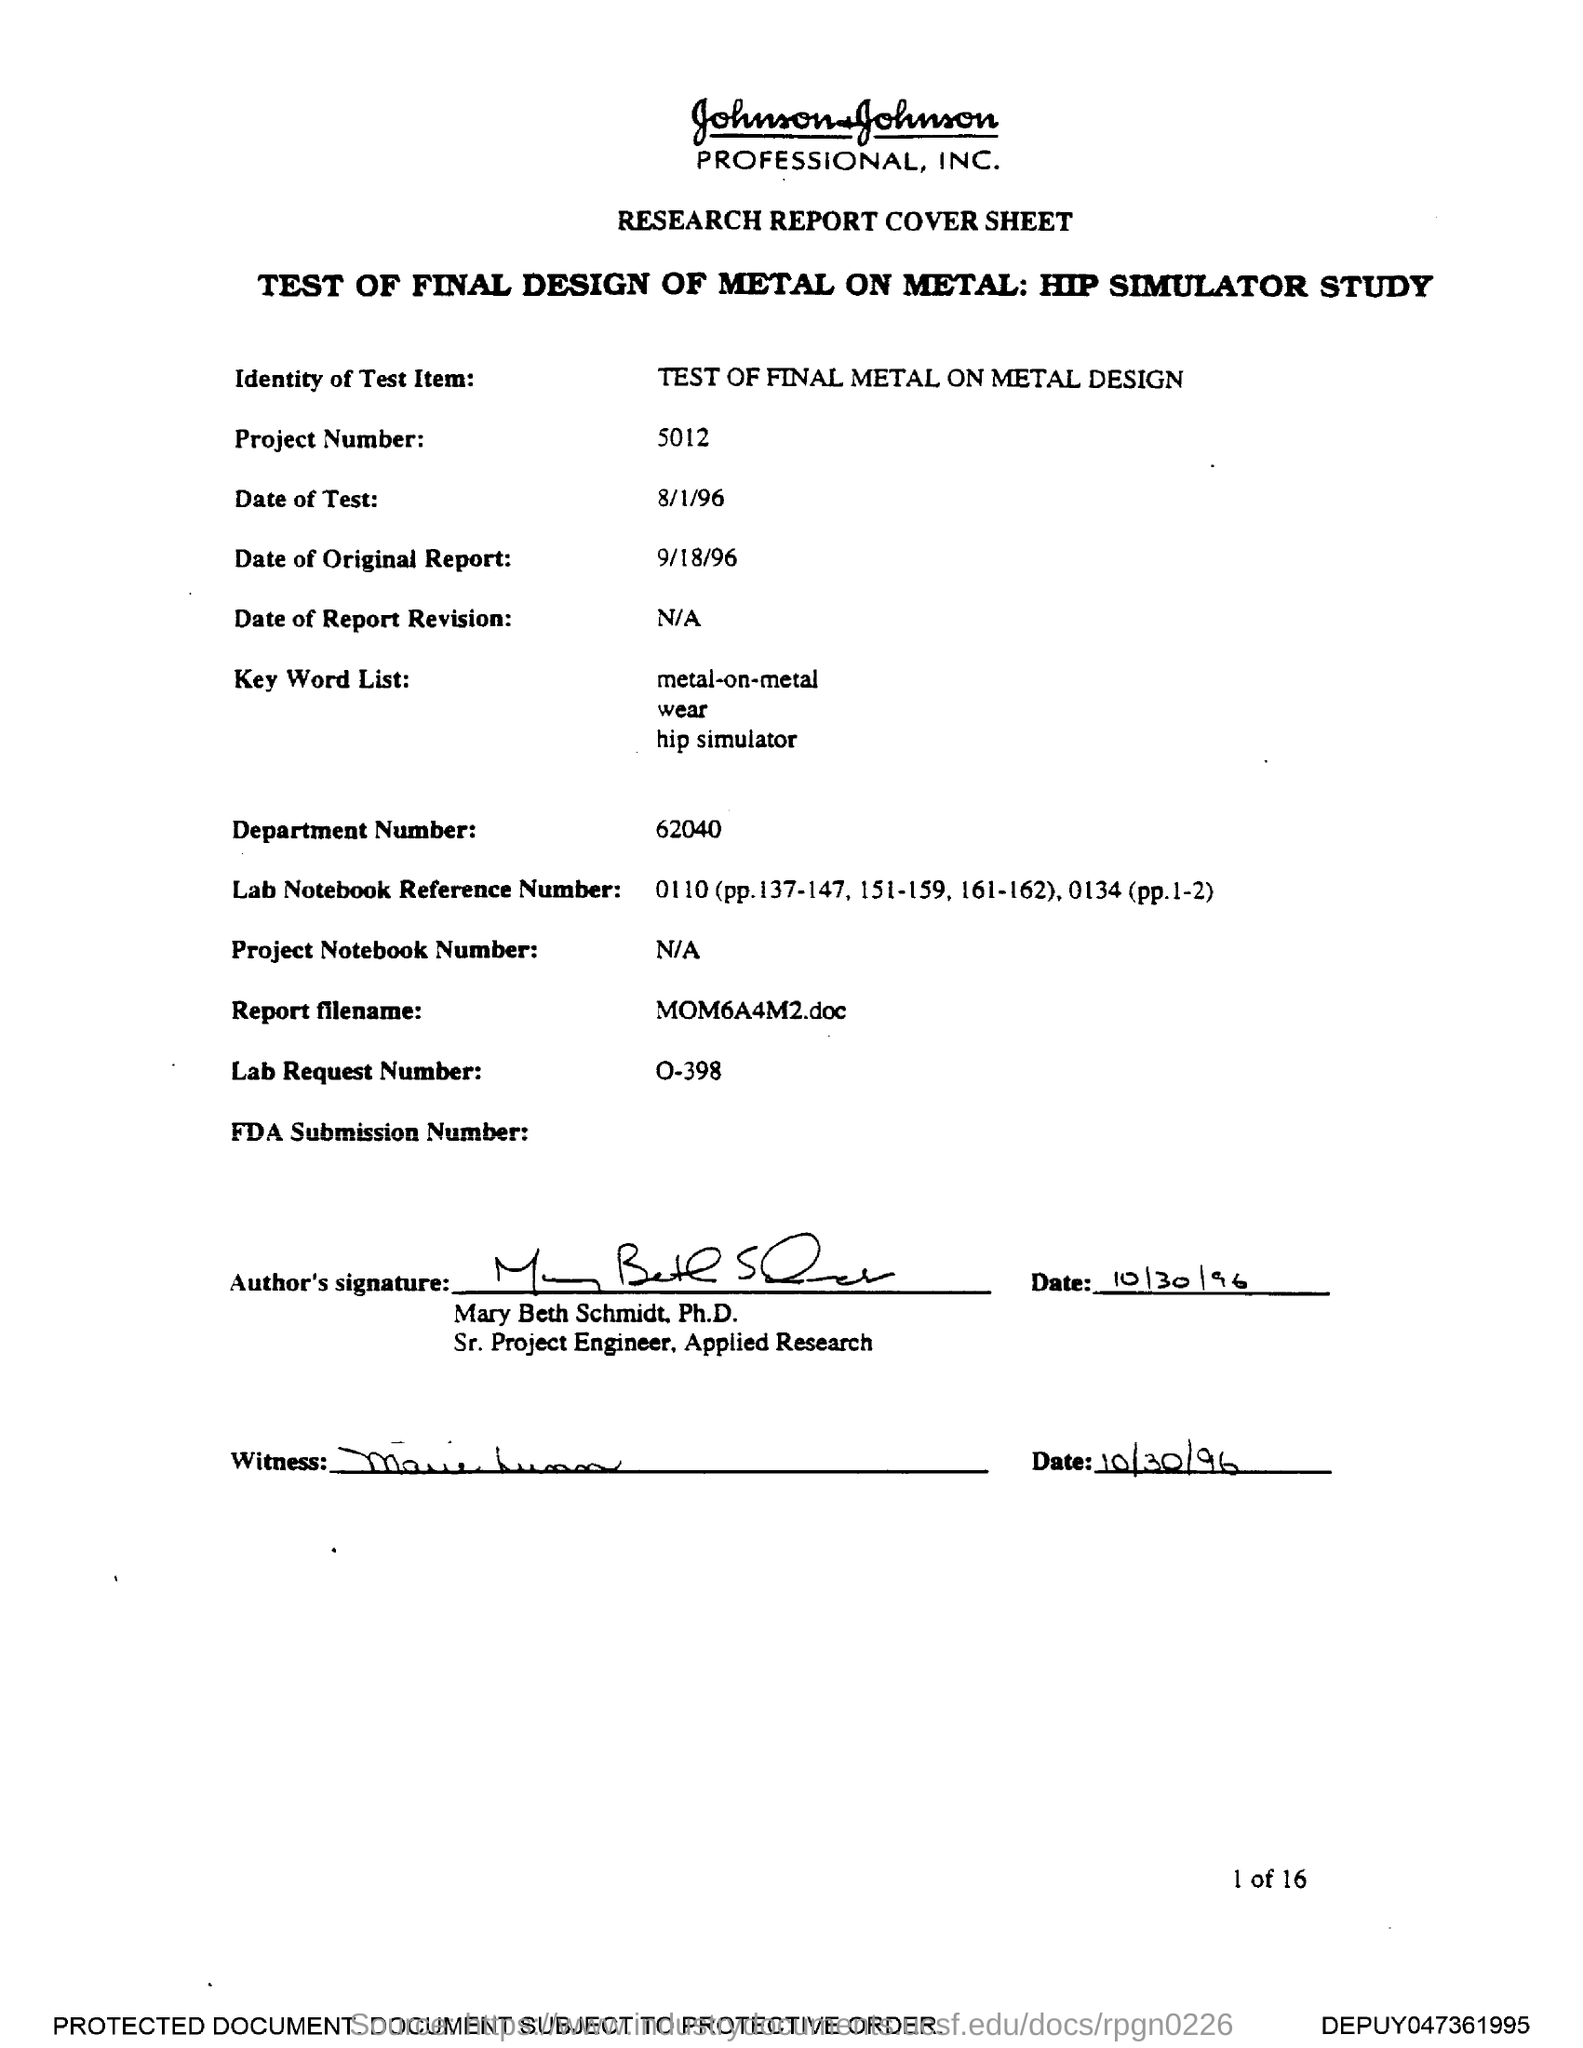What is the Project Number?
Provide a succinct answer. 5012. What is the Lab Request Number?
Offer a very short reply. O-398. What is the Department Number?
Keep it short and to the point. 62040. What is the Report filename?
Ensure brevity in your answer.  MOM6A4M2.doc. 